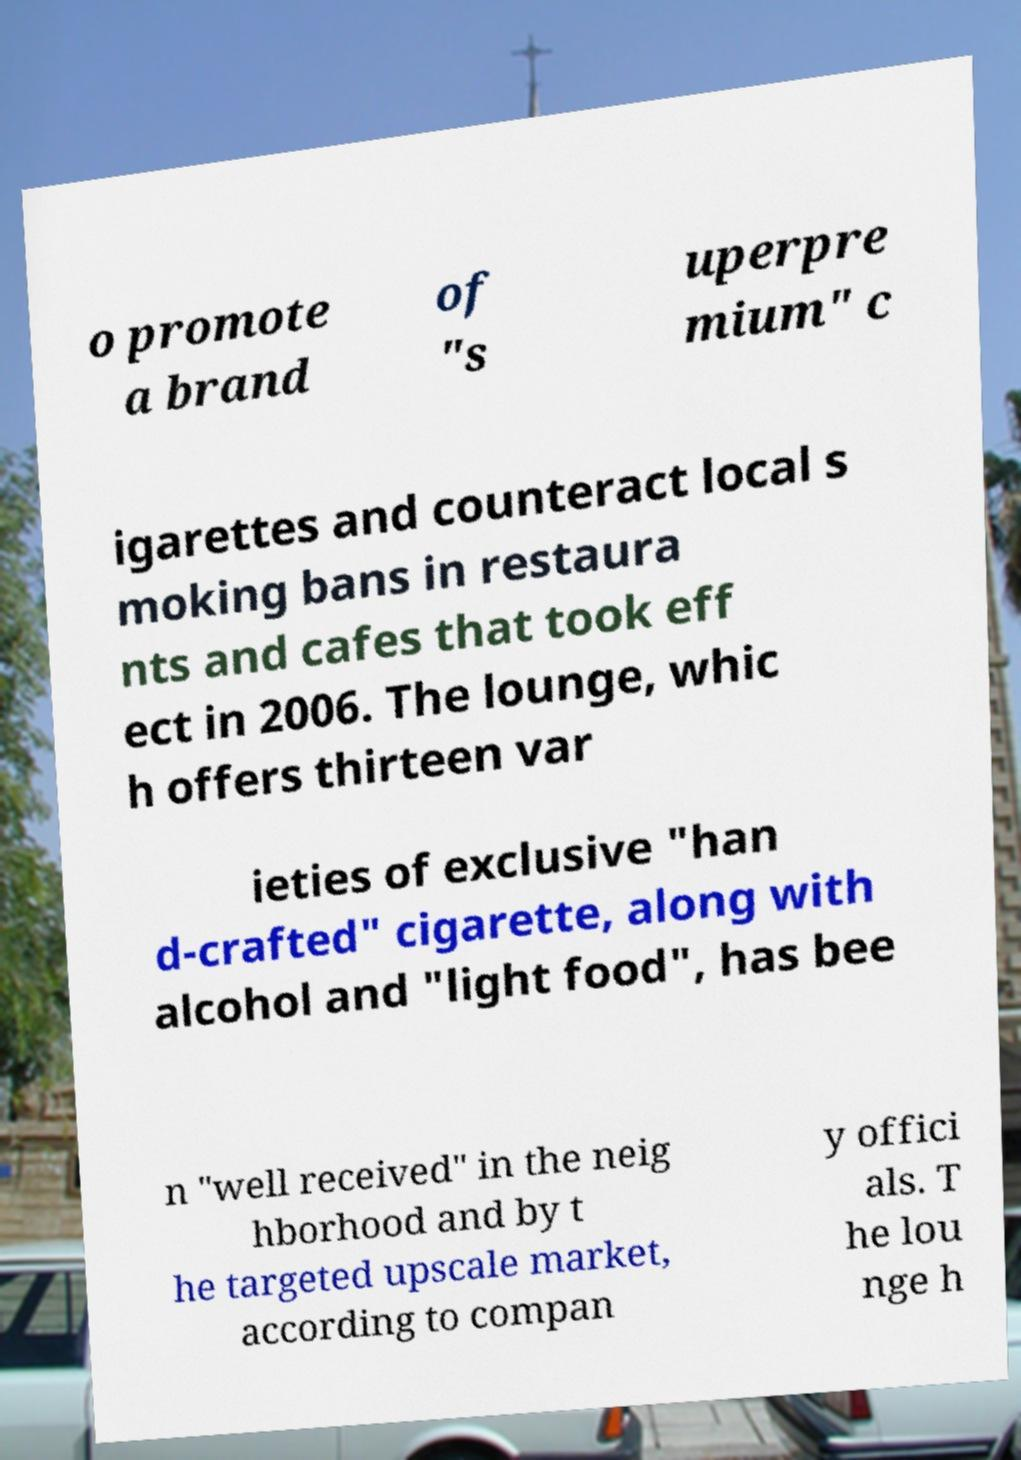Please identify and transcribe the text found in this image. o promote a brand of "s uperpre mium" c igarettes and counteract local s moking bans in restaura nts and cafes that took eff ect in 2006. The lounge, whic h offers thirteen var ieties of exclusive "han d-crafted" cigarette, along with alcohol and "light food", has bee n "well received" in the neig hborhood and by t he targeted upscale market, according to compan y offici als. T he lou nge h 